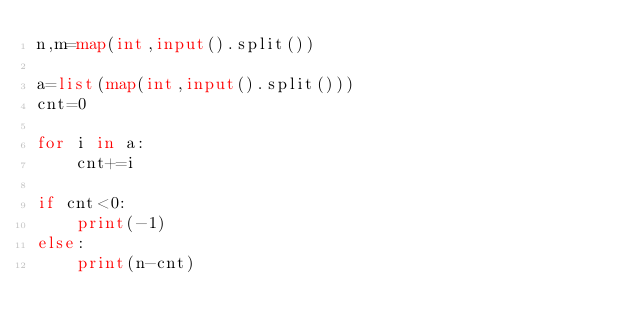<code> <loc_0><loc_0><loc_500><loc_500><_Python_>n,m=map(int,input().split())

a=list(map(int,input().split()))
cnt=0

for i in a:
    cnt+=i
   
if cnt<0:
    print(-1)
else:
    print(n-cnt)

</code> 